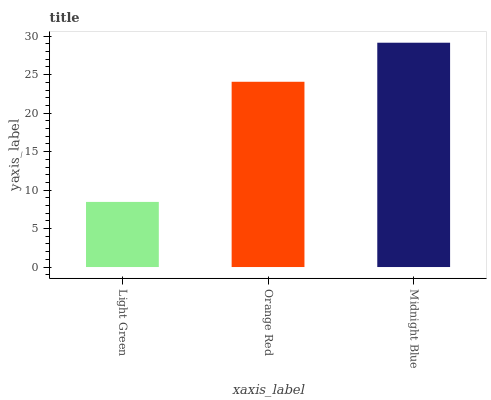Is Light Green the minimum?
Answer yes or no. Yes. Is Midnight Blue the maximum?
Answer yes or no. Yes. Is Orange Red the minimum?
Answer yes or no. No. Is Orange Red the maximum?
Answer yes or no. No. Is Orange Red greater than Light Green?
Answer yes or no. Yes. Is Light Green less than Orange Red?
Answer yes or no. Yes. Is Light Green greater than Orange Red?
Answer yes or no. No. Is Orange Red less than Light Green?
Answer yes or no. No. Is Orange Red the high median?
Answer yes or no. Yes. Is Orange Red the low median?
Answer yes or no. Yes. Is Light Green the high median?
Answer yes or no. No. Is Light Green the low median?
Answer yes or no. No. 